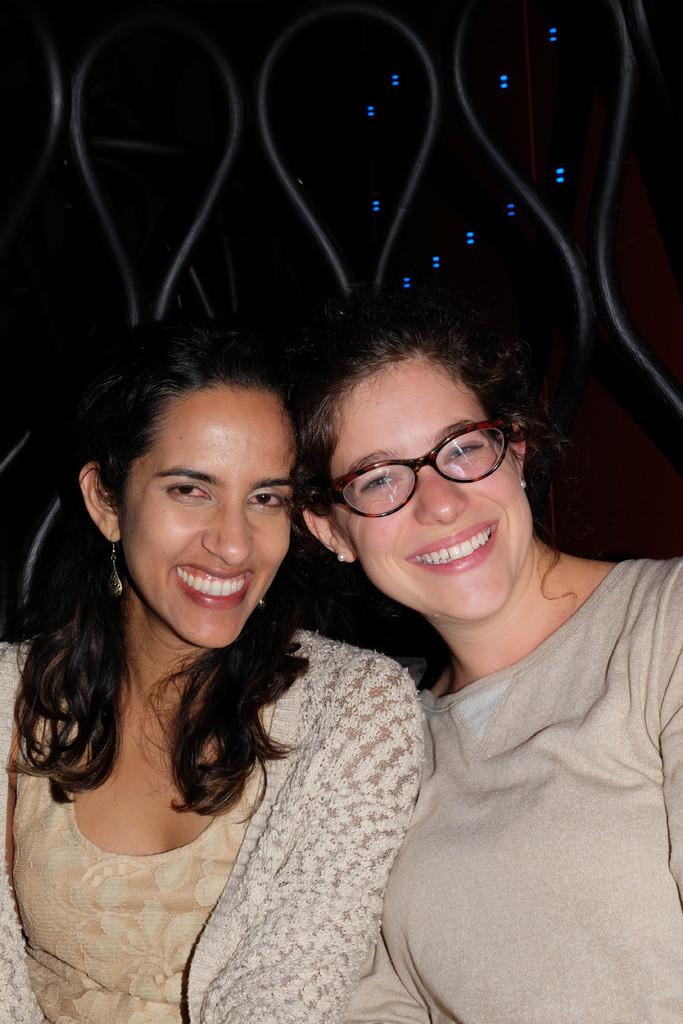How many people are in the image? There are two women in the image. What are the women wearing? The women are wearing grey color dresses. What expression do the women have? The women are smiling. What can be seen in the background of the image? There is a railing visible in the image. What type of yoke is being used by the women in the image? There is no yoke present in the image; the women are simply standing and smiling. How much money can be seen in the image? There is no money visible in the image. 